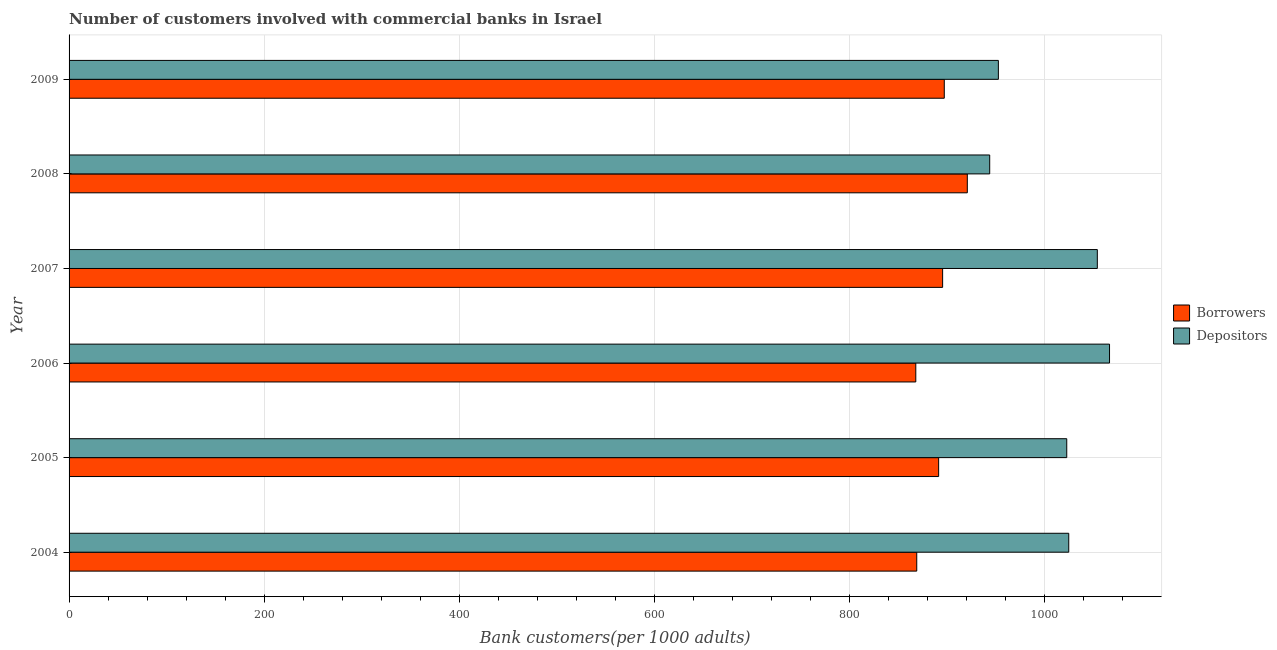Are the number of bars per tick equal to the number of legend labels?
Make the answer very short. Yes. How many bars are there on the 3rd tick from the top?
Offer a very short reply. 2. In how many cases, is the number of bars for a given year not equal to the number of legend labels?
Ensure brevity in your answer.  0. What is the number of borrowers in 2004?
Provide a short and direct response. 868.95. Across all years, what is the maximum number of depositors?
Your answer should be very brief. 1066.56. Across all years, what is the minimum number of borrowers?
Provide a short and direct response. 867.97. In which year was the number of borrowers minimum?
Ensure brevity in your answer.  2006. What is the total number of borrowers in the graph?
Your answer should be compact. 5341.7. What is the difference between the number of depositors in 2007 and that in 2009?
Offer a terse response. 101.44. What is the difference between the number of borrowers in 2009 and the number of depositors in 2006?
Your answer should be compact. -169.4. What is the average number of borrowers per year?
Offer a terse response. 890.28. In the year 2005, what is the difference between the number of borrowers and number of depositors?
Offer a very short reply. -131.31. In how many years, is the number of depositors greater than 240 ?
Keep it short and to the point. 6. What is the ratio of the number of depositors in 2006 to that in 2008?
Make the answer very short. 1.13. Is the difference between the number of borrowers in 2004 and 2009 greater than the difference between the number of depositors in 2004 and 2009?
Keep it short and to the point. No. What is the difference between the highest and the second highest number of depositors?
Provide a short and direct response. 12.5. What is the difference between the highest and the lowest number of borrowers?
Ensure brevity in your answer.  52.8. What does the 2nd bar from the top in 2004 represents?
Provide a short and direct response. Borrowers. What does the 1st bar from the bottom in 2006 represents?
Your response must be concise. Borrowers. How many bars are there?
Provide a succinct answer. 12. Are all the bars in the graph horizontal?
Your answer should be very brief. Yes. How many years are there in the graph?
Keep it short and to the point. 6. What is the difference between two consecutive major ticks on the X-axis?
Offer a very short reply. 200. Does the graph contain any zero values?
Your answer should be compact. No. Does the graph contain grids?
Offer a terse response. Yes. Where does the legend appear in the graph?
Make the answer very short. Center right. How many legend labels are there?
Your answer should be very brief. 2. How are the legend labels stacked?
Ensure brevity in your answer.  Vertical. What is the title of the graph?
Make the answer very short. Number of customers involved with commercial banks in Israel. What is the label or title of the X-axis?
Make the answer very short. Bank customers(per 1000 adults). What is the Bank customers(per 1000 adults) in Borrowers in 2004?
Provide a succinct answer. 868.95. What is the Bank customers(per 1000 adults) of Depositors in 2004?
Make the answer very short. 1024.76. What is the Bank customers(per 1000 adults) in Borrowers in 2005?
Make the answer very short. 891.39. What is the Bank customers(per 1000 adults) in Depositors in 2005?
Give a very brief answer. 1022.7. What is the Bank customers(per 1000 adults) in Borrowers in 2006?
Give a very brief answer. 867.97. What is the Bank customers(per 1000 adults) of Depositors in 2006?
Your answer should be very brief. 1066.56. What is the Bank customers(per 1000 adults) of Borrowers in 2007?
Keep it short and to the point. 895.46. What is the Bank customers(per 1000 adults) of Depositors in 2007?
Your answer should be very brief. 1054.06. What is the Bank customers(per 1000 adults) of Borrowers in 2008?
Keep it short and to the point. 920.77. What is the Bank customers(per 1000 adults) in Depositors in 2008?
Provide a short and direct response. 943.72. What is the Bank customers(per 1000 adults) in Borrowers in 2009?
Give a very brief answer. 897.16. What is the Bank customers(per 1000 adults) of Depositors in 2009?
Your answer should be compact. 952.62. Across all years, what is the maximum Bank customers(per 1000 adults) of Borrowers?
Your answer should be very brief. 920.77. Across all years, what is the maximum Bank customers(per 1000 adults) in Depositors?
Make the answer very short. 1066.56. Across all years, what is the minimum Bank customers(per 1000 adults) of Borrowers?
Your answer should be very brief. 867.97. Across all years, what is the minimum Bank customers(per 1000 adults) of Depositors?
Your answer should be very brief. 943.72. What is the total Bank customers(per 1000 adults) of Borrowers in the graph?
Offer a terse response. 5341.7. What is the total Bank customers(per 1000 adults) in Depositors in the graph?
Offer a terse response. 6064.43. What is the difference between the Bank customers(per 1000 adults) of Borrowers in 2004 and that in 2005?
Provide a short and direct response. -22.44. What is the difference between the Bank customers(per 1000 adults) of Depositors in 2004 and that in 2005?
Offer a very short reply. 2.06. What is the difference between the Bank customers(per 1000 adults) of Borrowers in 2004 and that in 2006?
Offer a terse response. 0.99. What is the difference between the Bank customers(per 1000 adults) of Depositors in 2004 and that in 2006?
Your answer should be compact. -41.8. What is the difference between the Bank customers(per 1000 adults) in Borrowers in 2004 and that in 2007?
Your answer should be compact. -26.51. What is the difference between the Bank customers(per 1000 adults) in Depositors in 2004 and that in 2007?
Provide a short and direct response. -29.3. What is the difference between the Bank customers(per 1000 adults) of Borrowers in 2004 and that in 2008?
Keep it short and to the point. -51.82. What is the difference between the Bank customers(per 1000 adults) of Depositors in 2004 and that in 2008?
Provide a succinct answer. 81.04. What is the difference between the Bank customers(per 1000 adults) in Borrowers in 2004 and that in 2009?
Offer a terse response. -28.21. What is the difference between the Bank customers(per 1000 adults) of Depositors in 2004 and that in 2009?
Offer a very short reply. 72.14. What is the difference between the Bank customers(per 1000 adults) of Borrowers in 2005 and that in 2006?
Keep it short and to the point. 23.42. What is the difference between the Bank customers(per 1000 adults) of Depositors in 2005 and that in 2006?
Ensure brevity in your answer.  -43.86. What is the difference between the Bank customers(per 1000 adults) in Borrowers in 2005 and that in 2007?
Your answer should be very brief. -4.08. What is the difference between the Bank customers(per 1000 adults) of Depositors in 2005 and that in 2007?
Your answer should be compact. -31.36. What is the difference between the Bank customers(per 1000 adults) of Borrowers in 2005 and that in 2008?
Ensure brevity in your answer.  -29.38. What is the difference between the Bank customers(per 1000 adults) in Depositors in 2005 and that in 2008?
Give a very brief answer. 78.98. What is the difference between the Bank customers(per 1000 adults) of Borrowers in 2005 and that in 2009?
Offer a terse response. -5.77. What is the difference between the Bank customers(per 1000 adults) in Depositors in 2005 and that in 2009?
Offer a terse response. 70.08. What is the difference between the Bank customers(per 1000 adults) in Borrowers in 2006 and that in 2007?
Ensure brevity in your answer.  -27.5. What is the difference between the Bank customers(per 1000 adults) of Depositors in 2006 and that in 2007?
Keep it short and to the point. 12.5. What is the difference between the Bank customers(per 1000 adults) in Borrowers in 2006 and that in 2008?
Provide a succinct answer. -52.8. What is the difference between the Bank customers(per 1000 adults) in Depositors in 2006 and that in 2008?
Ensure brevity in your answer.  122.84. What is the difference between the Bank customers(per 1000 adults) in Borrowers in 2006 and that in 2009?
Keep it short and to the point. -29.19. What is the difference between the Bank customers(per 1000 adults) in Depositors in 2006 and that in 2009?
Make the answer very short. 113.94. What is the difference between the Bank customers(per 1000 adults) in Borrowers in 2007 and that in 2008?
Your answer should be very brief. -25.3. What is the difference between the Bank customers(per 1000 adults) of Depositors in 2007 and that in 2008?
Your answer should be very brief. 110.33. What is the difference between the Bank customers(per 1000 adults) of Borrowers in 2007 and that in 2009?
Offer a very short reply. -1.7. What is the difference between the Bank customers(per 1000 adults) in Depositors in 2007 and that in 2009?
Keep it short and to the point. 101.44. What is the difference between the Bank customers(per 1000 adults) in Borrowers in 2008 and that in 2009?
Give a very brief answer. 23.61. What is the difference between the Bank customers(per 1000 adults) in Depositors in 2008 and that in 2009?
Provide a succinct answer. -8.9. What is the difference between the Bank customers(per 1000 adults) of Borrowers in 2004 and the Bank customers(per 1000 adults) of Depositors in 2005?
Your answer should be very brief. -153.75. What is the difference between the Bank customers(per 1000 adults) of Borrowers in 2004 and the Bank customers(per 1000 adults) of Depositors in 2006?
Your answer should be very brief. -197.61. What is the difference between the Bank customers(per 1000 adults) in Borrowers in 2004 and the Bank customers(per 1000 adults) in Depositors in 2007?
Offer a very short reply. -185.11. What is the difference between the Bank customers(per 1000 adults) of Borrowers in 2004 and the Bank customers(per 1000 adults) of Depositors in 2008?
Ensure brevity in your answer.  -74.77. What is the difference between the Bank customers(per 1000 adults) in Borrowers in 2004 and the Bank customers(per 1000 adults) in Depositors in 2009?
Offer a terse response. -83.67. What is the difference between the Bank customers(per 1000 adults) in Borrowers in 2005 and the Bank customers(per 1000 adults) in Depositors in 2006?
Ensure brevity in your answer.  -175.17. What is the difference between the Bank customers(per 1000 adults) in Borrowers in 2005 and the Bank customers(per 1000 adults) in Depositors in 2007?
Make the answer very short. -162.67. What is the difference between the Bank customers(per 1000 adults) of Borrowers in 2005 and the Bank customers(per 1000 adults) of Depositors in 2008?
Your answer should be compact. -52.34. What is the difference between the Bank customers(per 1000 adults) in Borrowers in 2005 and the Bank customers(per 1000 adults) in Depositors in 2009?
Provide a succinct answer. -61.23. What is the difference between the Bank customers(per 1000 adults) of Borrowers in 2006 and the Bank customers(per 1000 adults) of Depositors in 2007?
Make the answer very short. -186.09. What is the difference between the Bank customers(per 1000 adults) of Borrowers in 2006 and the Bank customers(per 1000 adults) of Depositors in 2008?
Your answer should be compact. -75.76. What is the difference between the Bank customers(per 1000 adults) of Borrowers in 2006 and the Bank customers(per 1000 adults) of Depositors in 2009?
Provide a succinct answer. -84.66. What is the difference between the Bank customers(per 1000 adults) in Borrowers in 2007 and the Bank customers(per 1000 adults) in Depositors in 2008?
Provide a succinct answer. -48.26. What is the difference between the Bank customers(per 1000 adults) of Borrowers in 2007 and the Bank customers(per 1000 adults) of Depositors in 2009?
Ensure brevity in your answer.  -57.16. What is the difference between the Bank customers(per 1000 adults) in Borrowers in 2008 and the Bank customers(per 1000 adults) in Depositors in 2009?
Offer a terse response. -31.85. What is the average Bank customers(per 1000 adults) of Borrowers per year?
Offer a very short reply. 890.28. What is the average Bank customers(per 1000 adults) of Depositors per year?
Give a very brief answer. 1010.74. In the year 2004, what is the difference between the Bank customers(per 1000 adults) in Borrowers and Bank customers(per 1000 adults) in Depositors?
Keep it short and to the point. -155.81. In the year 2005, what is the difference between the Bank customers(per 1000 adults) of Borrowers and Bank customers(per 1000 adults) of Depositors?
Offer a very short reply. -131.31. In the year 2006, what is the difference between the Bank customers(per 1000 adults) of Borrowers and Bank customers(per 1000 adults) of Depositors?
Make the answer very short. -198.6. In the year 2007, what is the difference between the Bank customers(per 1000 adults) in Borrowers and Bank customers(per 1000 adults) in Depositors?
Your answer should be compact. -158.59. In the year 2008, what is the difference between the Bank customers(per 1000 adults) of Borrowers and Bank customers(per 1000 adults) of Depositors?
Provide a short and direct response. -22.96. In the year 2009, what is the difference between the Bank customers(per 1000 adults) of Borrowers and Bank customers(per 1000 adults) of Depositors?
Offer a terse response. -55.46. What is the ratio of the Bank customers(per 1000 adults) in Borrowers in 2004 to that in 2005?
Provide a short and direct response. 0.97. What is the ratio of the Bank customers(per 1000 adults) of Depositors in 2004 to that in 2005?
Make the answer very short. 1. What is the ratio of the Bank customers(per 1000 adults) in Borrowers in 2004 to that in 2006?
Keep it short and to the point. 1. What is the ratio of the Bank customers(per 1000 adults) of Depositors in 2004 to that in 2006?
Your response must be concise. 0.96. What is the ratio of the Bank customers(per 1000 adults) in Borrowers in 2004 to that in 2007?
Make the answer very short. 0.97. What is the ratio of the Bank customers(per 1000 adults) in Depositors in 2004 to that in 2007?
Offer a terse response. 0.97. What is the ratio of the Bank customers(per 1000 adults) of Borrowers in 2004 to that in 2008?
Your answer should be very brief. 0.94. What is the ratio of the Bank customers(per 1000 adults) of Depositors in 2004 to that in 2008?
Ensure brevity in your answer.  1.09. What is the ratio of the Bank customers(per 1000 adults) of Borrowers in 2004 to that in 2009?
Ensure brevity in your answer.  0.97. What is the ratio of the Bank customers(per 1000 adults) of Depositors in 2004 to that in 2009?
Offer a terse response. 1.08. What is the ratio of the Bank customers(per 1000 adults) of Borrowers in 2005 to that in 2006?
Offer a very short reply. 1.03. What is the ratio of the Bank customers(per 1000 adults) of Depositors in 2005 to that in 2006?
Offer a very short reply. 0.96. What is the ratio of the Bank customers(per 1000 adults) in Depositors in 2005 to that in 2007?
Offer a terse response. 0.97. What is the ratio of the Bank customers(per 1000 adults) of Borrowers in 2005 to that in 2008?
Give a very brief answer. 0.97. What is the ratio of the Bank customers(per 1000 adults) in Depositors in 2005 to that in 2008?
Ensure brevity in your answer.  1.08. What is the ratio of the Bank customers(per 1000 adults) of Depositors in 2005 to that in 2009?
Offer a terse response. 1.07. What is the ratio of the Bank customers(per 1000 adults) of Borrowers in 2006 to that in 2007?
Your answer should be compact. 0.97. What is the ratio of the Bank customers(per 1000 adults) in Depositors in 2006 to that in 2007?
Offer a very short reply. 1.01. What is the ratio of the Bank customers(per 1000 adults) of Borrowers in 2006 to that in 2008?
Offer a terse response. 0.94. What is the ratio of the Bank customers(per 1000 adults) of Depositors in 2006 to that in 2008?
Offer a terse response. 1.13. What is the ratio of the Bank customers(per 1000 adults) of Borrowers in 2006 to that in 2009?
Give a very brief answer. 0.97. What is the ratio of the Bank customers(per 1000 adults) of Depositors in 2006 to that in 2009?
Provide a succinct answer. 1.12. What is the ratio of the Bank customers(per 1000 adults) of Borrowers in 2007 to that in 2008?
Give a very brief answer. 0.97. What is the ratio of the Bank customers(per 1000 adults) in Depositors in 2007 to that in 2008?
Make the answer very short. 1.12. What is the ratio of the Bank customers(per 1000 adults) of Borrowers in 2007 to that in 2009?
Your response must be concise. 1. What is the ratio of the Bank customers(per 1000 adults) of Depositors in 2007 to that in 2009?
Your answer should be very brief. 1.11. What is the ratio of the Bank customers(per 1000 adults) in Borrowers in 2008 to that in 2009?
Provide a succinct answer. 1.03. What is the ratio of the Bank customers(per 1000 adults) of Depositors in 2008 to that in 2009?
Give a very brief answer. 0.99. What is the difference between the highest and the second highest Bank customers(per 1000 adults) in Borrowers?
Provide a succinct answer. 23.61. What is the difference between the highest and the second highest Bank customers(per 1000 adults) of Depositors?
Keep it short and to the point. 12.5. What is the difference between the highest and the lowest Bank customers(per 1000 adults) of Borrowers?
Provide a succinct answer. 52.8. What is the difference between the highest and the lowest Bank customers(per 1000 adults) in Depositors?
Your answer should be compact. 122.84. 